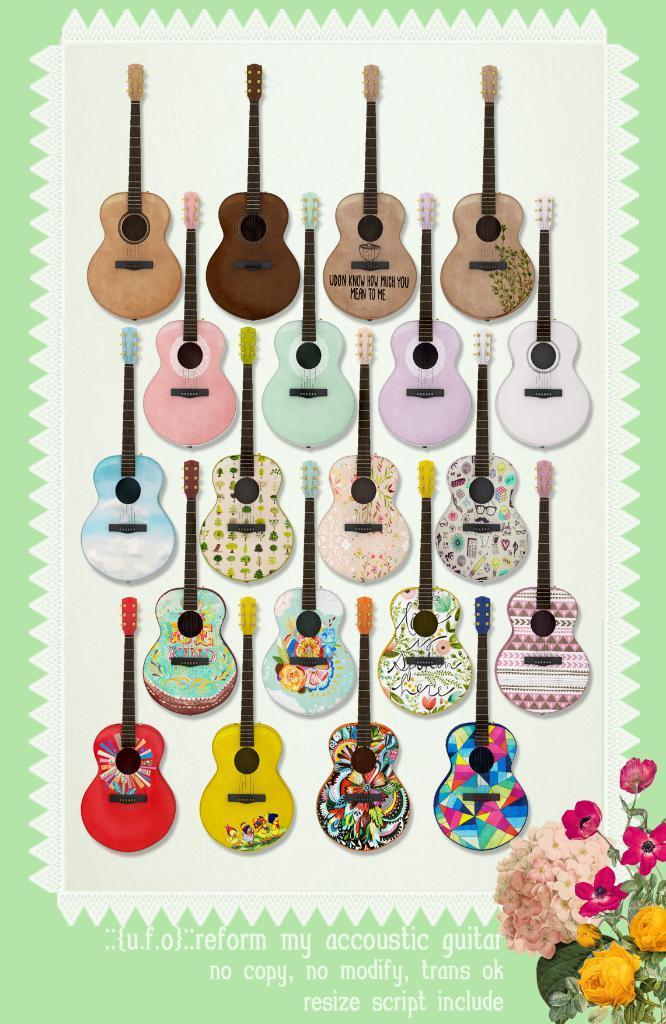Could you give a brief overview of what you see in this image? In this image I can see many guitars which are colorful. I can see something is written. To the right bottom of the image I can see the flowers which are in yellow and pink color. 